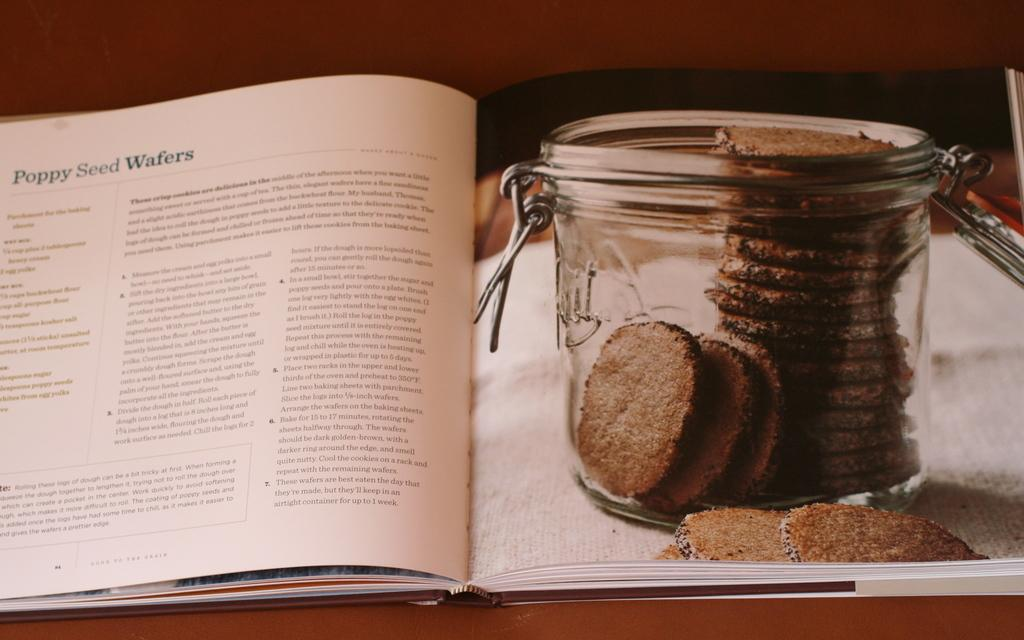<image>
Offer a succinct explanation of the picture presented. A recipe book is open at a recipe for poppy seed wafers 